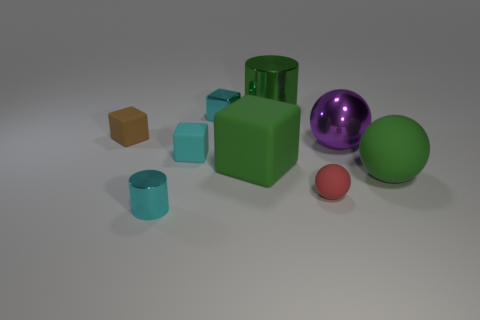Subtract all purple metallic balls. How many balls are left? 2 Add 1 large metal things. How many objects exist? 10 Subtract all cyan cubes. How many cubes are left? 2 Subtract 0 gray spheres. How many objects are left? 9 Subtract all cubes. How many objects are left? 5 Subtract 1 cylinders. How many cylinders are left? 1 Subtract all gray blocks. Subtract all green cylinders. How many blocks are left? 4 Subtract all red balls. How many cyan cylinders are left? 1 Subtract all large brown blocks. Subtract all big green rubber blocks. How many objects are left? 8 Add 6 cyan rubber things. How many cyan rubber things are left? 7 